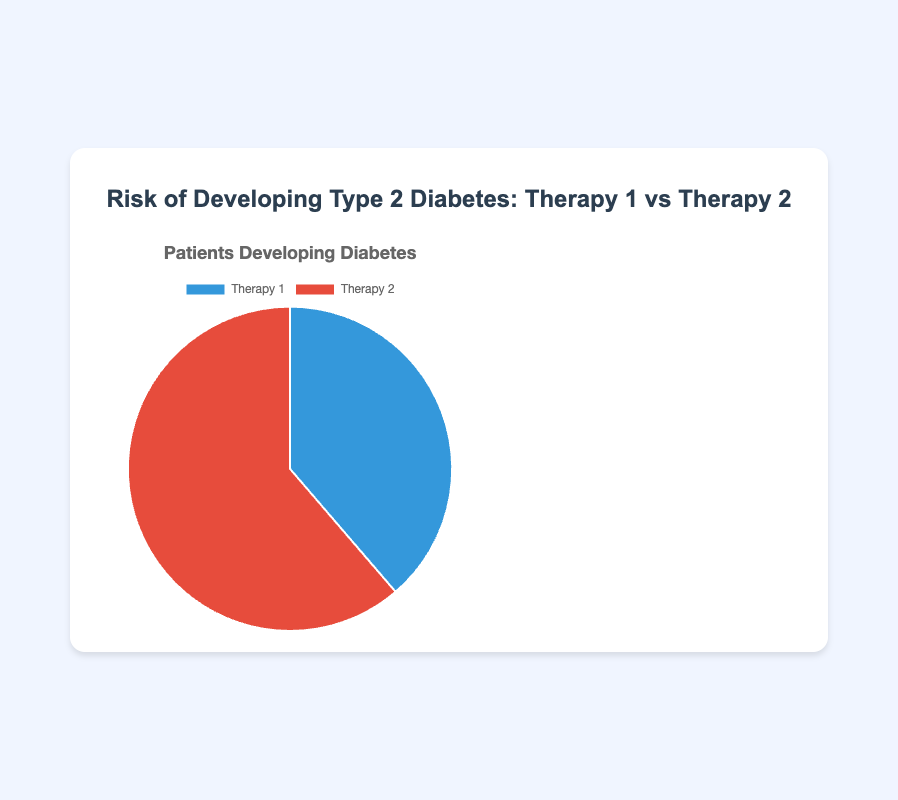What is the total number of patients developing diabetes on Therapy 1? The figure shows that there are 180 patients developing diabetes on Therapy 1 across all treatments. Simply refer to the segment representing Therapy 1 and accumulate the values.
Answer: 180 What is the difference in the number of patients developing diabetes between Therapy 1 and Therapy 2? The figure shows 180 patients developing diabetes on Therapy 1 and 285 on Therapy 2. The difference is 285 - 180 = 105.
Answer: 105 Which therapy, between Therapy 1 and Therapy 2, has a greater number of patients developing diabetes? Therapy 2 has a greater number of patients developing diabetes, with a total of 285 compared to 180 for Therapy 1.
Answer: Therapy 2 By how many patients does Therapy 2 exceed Therapy 1 in terms of diabetes cases for the "Metformin" treatment? For "Metformin", Therapy 1 has 50 cases, and Therapy 2 has 65 cases of diabetes. The difference is 65 - 50 = 15.
Answer: 15 What percentage of all patients developing diabetes are on Therapy 2? The total number of patients developing diabetes is 180 + 285 = 465. The number for Therapy 2 is 285. The percentage is (285/465) * 100 ≈ 61.29%.
Answer: 61.29% Are there more patients developing diabetes on Therapy 1 or Therapy 2 for "Thiazolidinediones"? For "Thiazolidinediones", Therapy 1 has 25 patients developing diabetes, while Therapy 2 has 50. Therapy 2 has more patients.
Answer: Therapy 2 What is the sum of patients developing diabetes on Therapy 1 and Therapy 2 for "GLP-1 receptor agonists"? Therapy 1 has 35 patients, and Therapy 2 has 55 patients developing diabetes for "GLP-1 receptor agonists". The sum is 35 + 55 = 90.
Answer: 90 What is the average number of patients developing diabetes on Therapy 1 across all treatments? Therapy 1 diabetes cases: 50 (Metformin) + 40 (Sulfonylureas) + 25 (Thiazolidinediones) + 30 (DPP-4 inhibitors) + 35 (GLP-1 receptor agonists) = 180. There are 5 treatments, so the average is 180/5 = 36.
Answer: 36 What is the combined total number of patients developing diabetes for "Sulfonylureas" and "DPP-4 inhibitors" on Therapy 2? For Therapy 2, "Sulfonylureas" has 70 patients, and "DPP-4 inhibitors" has 45 patients developing diabetes. The sum is 70 + 45 = 115.
Answer: 115 Which segment, Therapy 1 or Therapy 2, is visually larger in the pie chart? Therapy 2 segment is visually larger, indicated by a larger area in the pie chart, representing 285 patients.
Answer: Therapy 2 